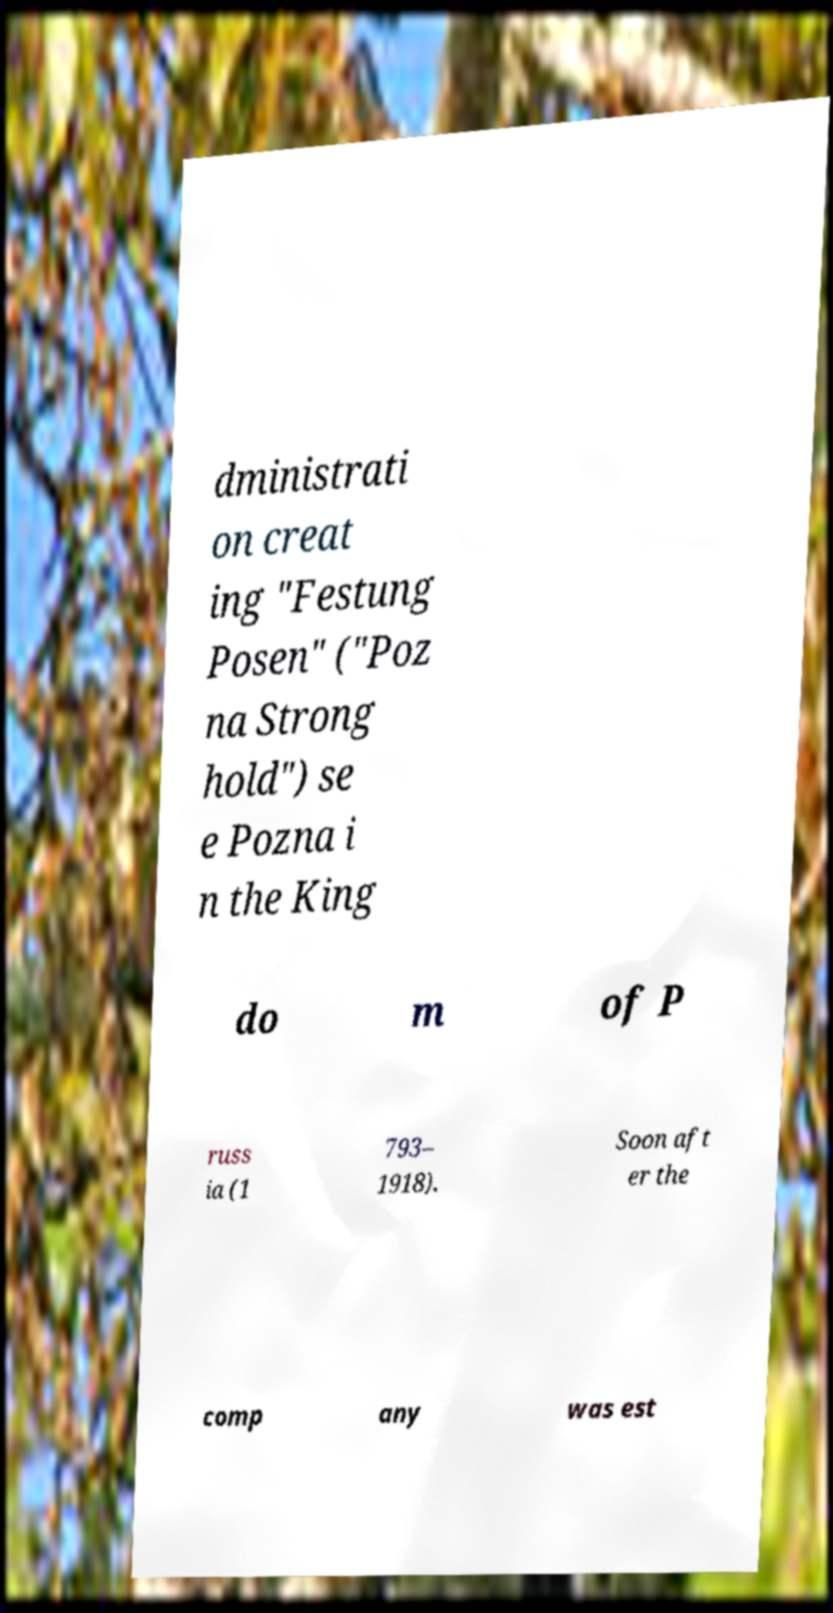Can you read and provide the text displayed in the image?This photo seems to have some interesting text. Can you extract and type it out for me? dministrati on creat ing "Festung Posen" ("Poz na Strong hold") se e Pozna i n the King do m of P russ ia (1 793– 1918). Soon aft er the comp any was est 